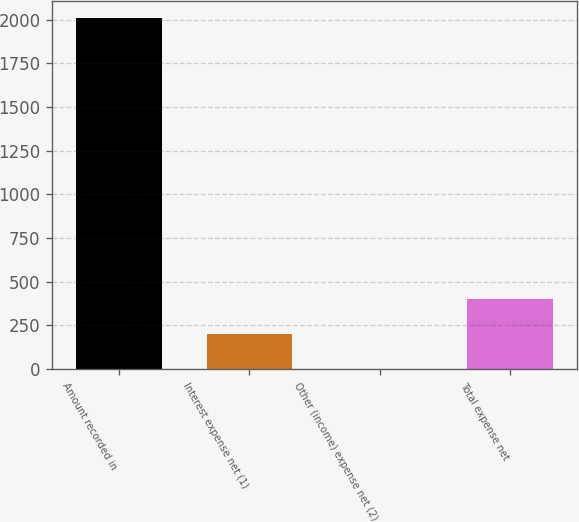Convert chart. <chart><loc_0><loc_0><loc_500><loc_500><bar_chart><fcel>Amount recorded in<fcel>Interest expense net (1)<fcel>Other (income) expense net (2)<fcel>Total expense net<nl><fcel>2008<fcel>201.34<fcel>0.6<fcel>402.08<nl></chart> 